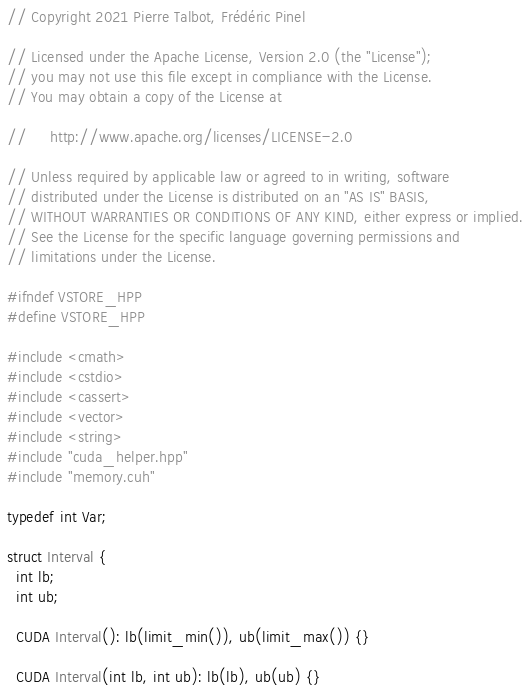<code> <loc_0><loc_0><loc_500><loc_500><_Cuda_>// Copyright 2021 Pierre Talbot, Frédéric Pinel

// Licensed under the Apache License, Version 2.0 (the "License");
// you may not use this file except in compliance with the License.
// You may obtain a copy of the License at

//     http://www.apache.org/licenses/LICENSE-2.0

// Unless required by applicable law or agreed to in writing, software
// distributed under the License is distributed on an "AS IS" BASIS,
// WITHOUT WARRANTIES OR CONDITIONS OF ANY KIND, either express or implied.
// See the License for the specific language governing permissions and
// limitations under the License.

#ifndef VSTORE_HPP
#define VSTORE_HPP

#include <cmath>
#include <cstdio>
#include <cassert>
#include <vector>
#include <string>
#include "cuda_helper.hpp"
#include "memory.cuh"

typedef int Var;

struct Interval {
  int lb;
  int ub;

  CUDA Interval(): lb(limit_min()), ub(limit_max()) {}

  CUDA Interval(int lb, int ub): lb(lb), ub(ub) {}
</code> 